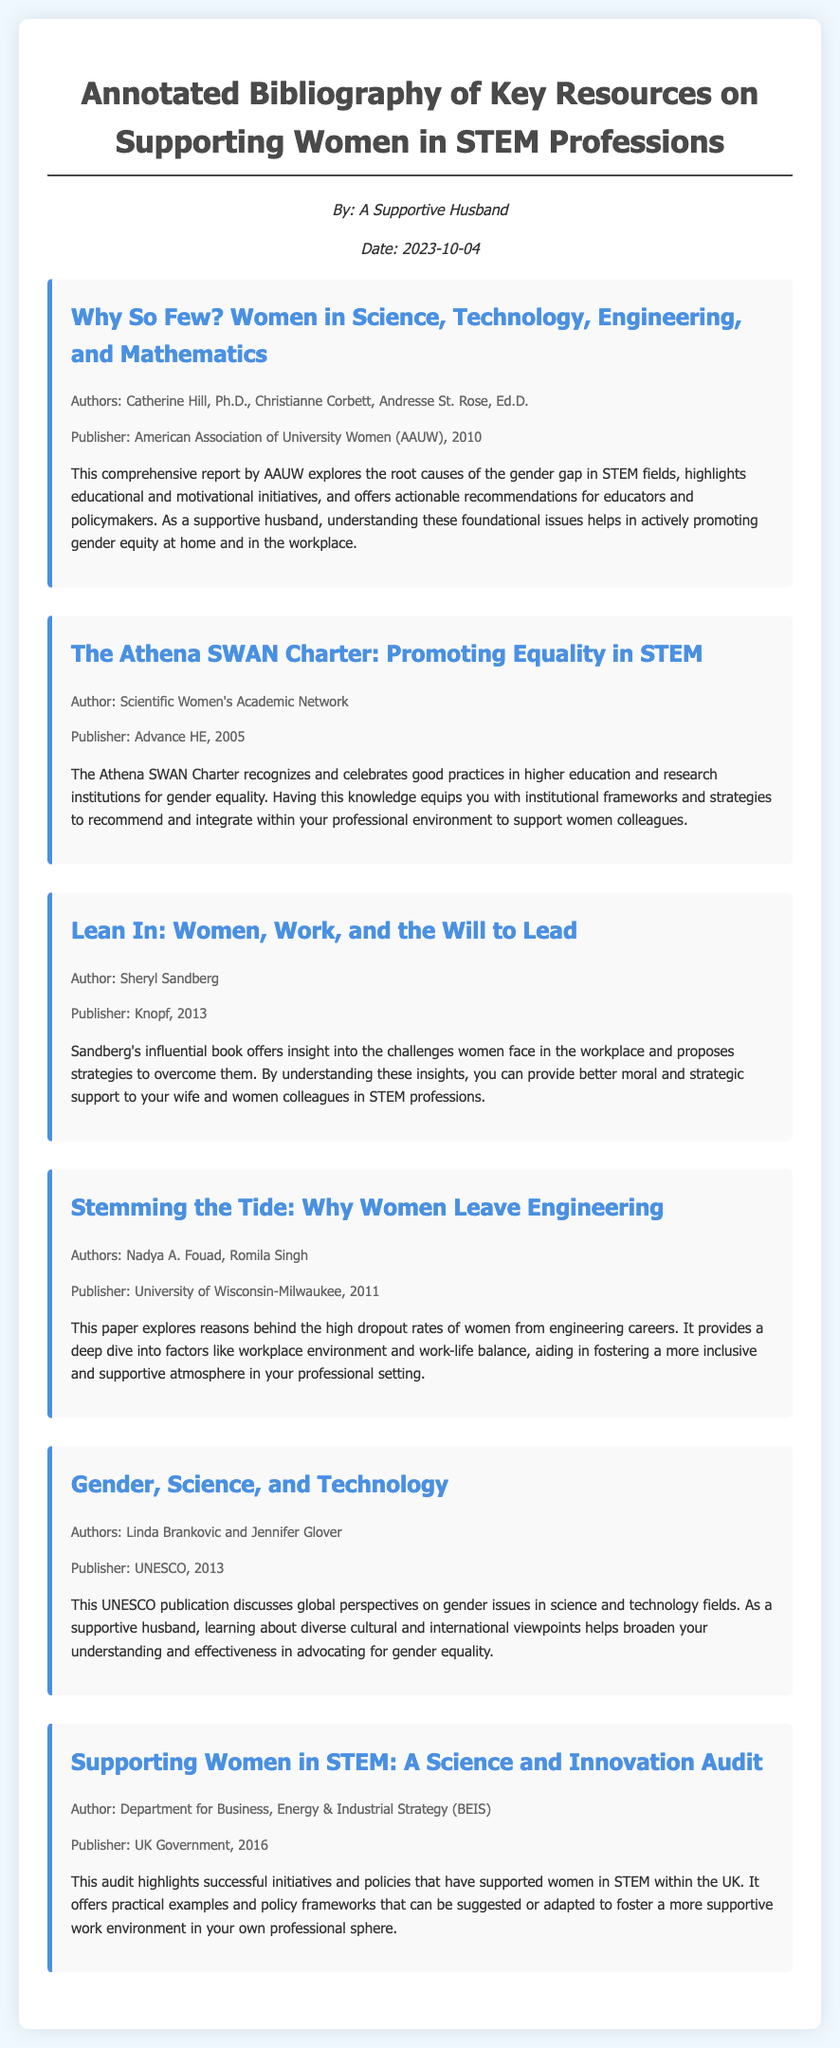What is the title of the first entry? The title of the first entry in the document is listed as "Why So Few? Women in Science, Technology, Engineering, and Mathematics."
Answer: Why So Few? Women in Science, Technology, Engineering, and Mathematics Who are the authors of the second entry? The authors of the second entry, titled "The Athena SWAN Charter: Promoting Equality in STEM," are specified as the Scientific Women's Academic Network.
Answer: Scientific Women's Academic Network What year was the book "Lean In" published? The year of publication for "Lean In: Women, Work, and the Will to Lead" is mentioned in the document as 2013.
Answer: 2013 What is one major theme discussed in "Stemming the Tide"? The paper "Stemming the Tide" explores the reasons behind high dropout rates of women in engineering, which is a significant theme highlighted in its content.
Answer: High dropout rates of women in engineering Who is the publisher of the resource authored by Linda Brankovic and Jennifer Glover? The publisher of "Gender, Science, and Technology" authored by Linda Brankovic and Jennifer Glover is stated as UNESCO.
Answer: UNESCO What type of report is "Why So Few?" The document categorizes "Why So Few?" as a comprehensive report addressing foundational issues in STEM related to gender equity.
Answer: Comprehensive report 